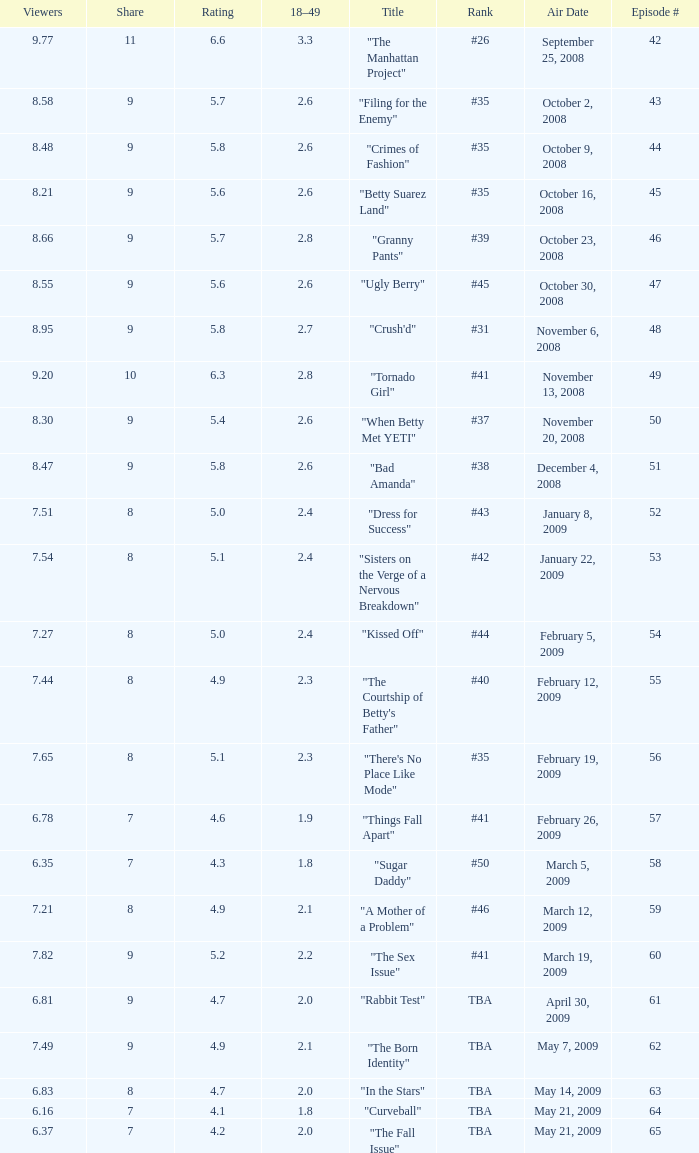What is the Air Date that has a 18–49 larger than 1.9, less than 7.54 viewers and a rating less than 4.9? April 30, 2009, May 14, 2009, May 21, 2009. 